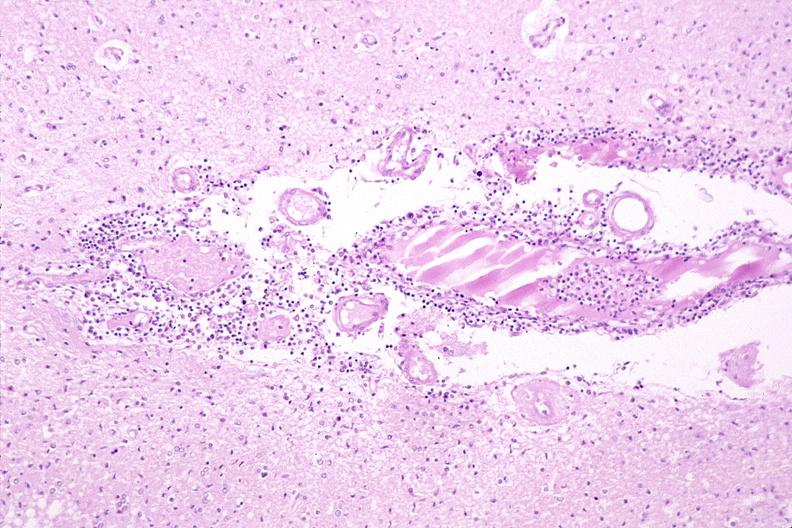where is this?
Answer the question using a single word or phrase. Nervous 